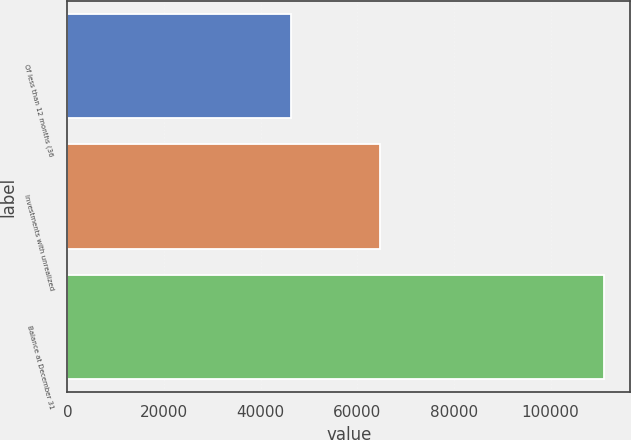<chart> <loc_0><loc_0><loc_500><loc_500><bar_chart><fcel>Of less than 12 months (36<fcel>Investments with unrealized<fcel>Balance at December 31<nl><fcel>46193<fcel>64769<fcel>110962<nl></chart> 